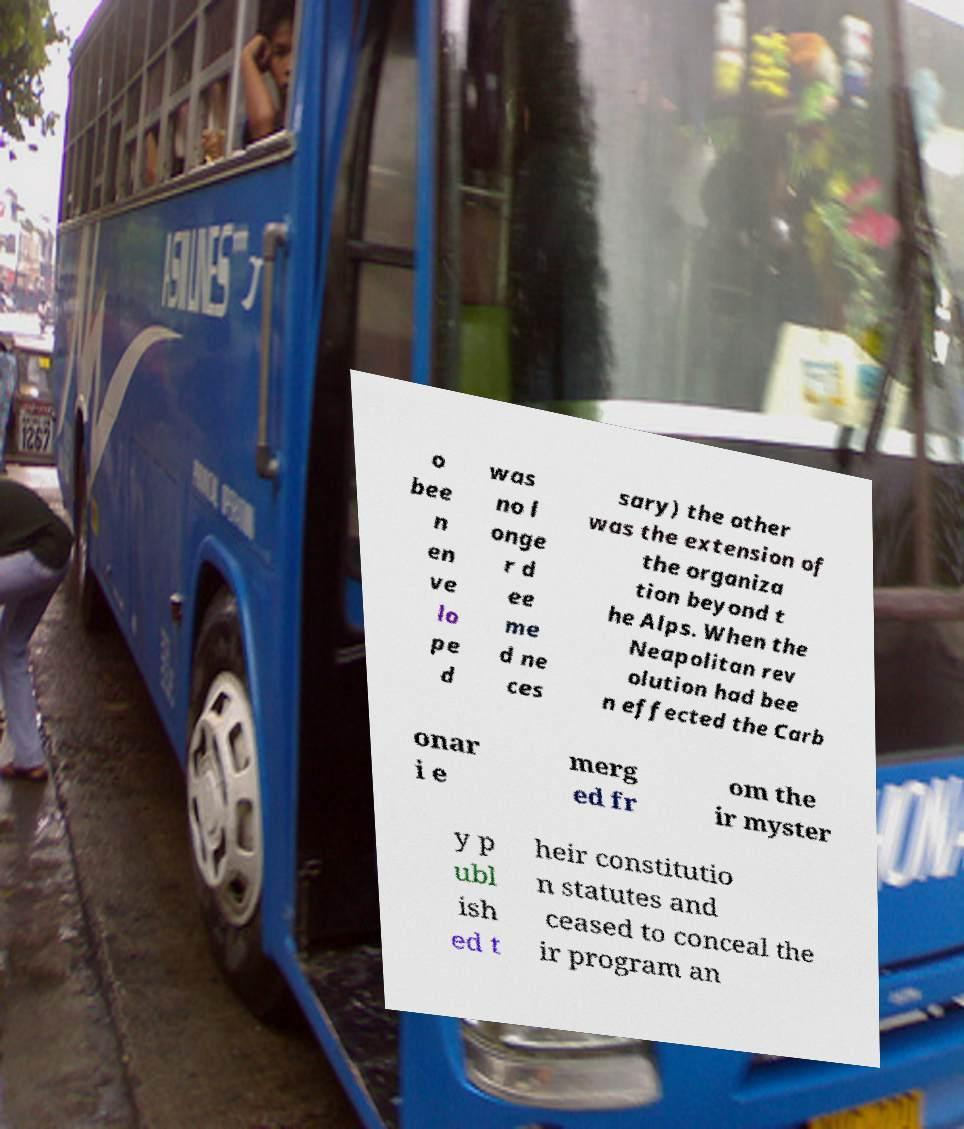Could you assist in decoding the text presented in this image and type it out clearly? o bee n en ve lo pe d was no l onge r d ee me d ne ces sary) the other was the extension of the organiza tion beyond t he Alps. When the Neapolitan rev olution had bee n effected the Carb onar i e merg ed fr om the ir myster y p ubl ish ed t heir constitutio n statutes and ceased to conceal the ir program an 